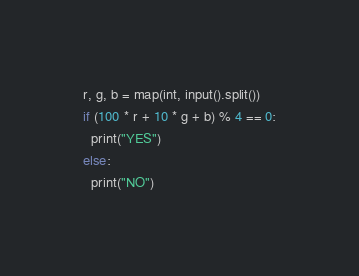Convert code to text. <code><loc_0><loc_0><loc_500><loc_500><_Python_>r, g, b = map(int, input().split())
if (100 * r + 10 * g + b) % 4 == 0:
  print("YES")
else:
  print("NO")</code> 